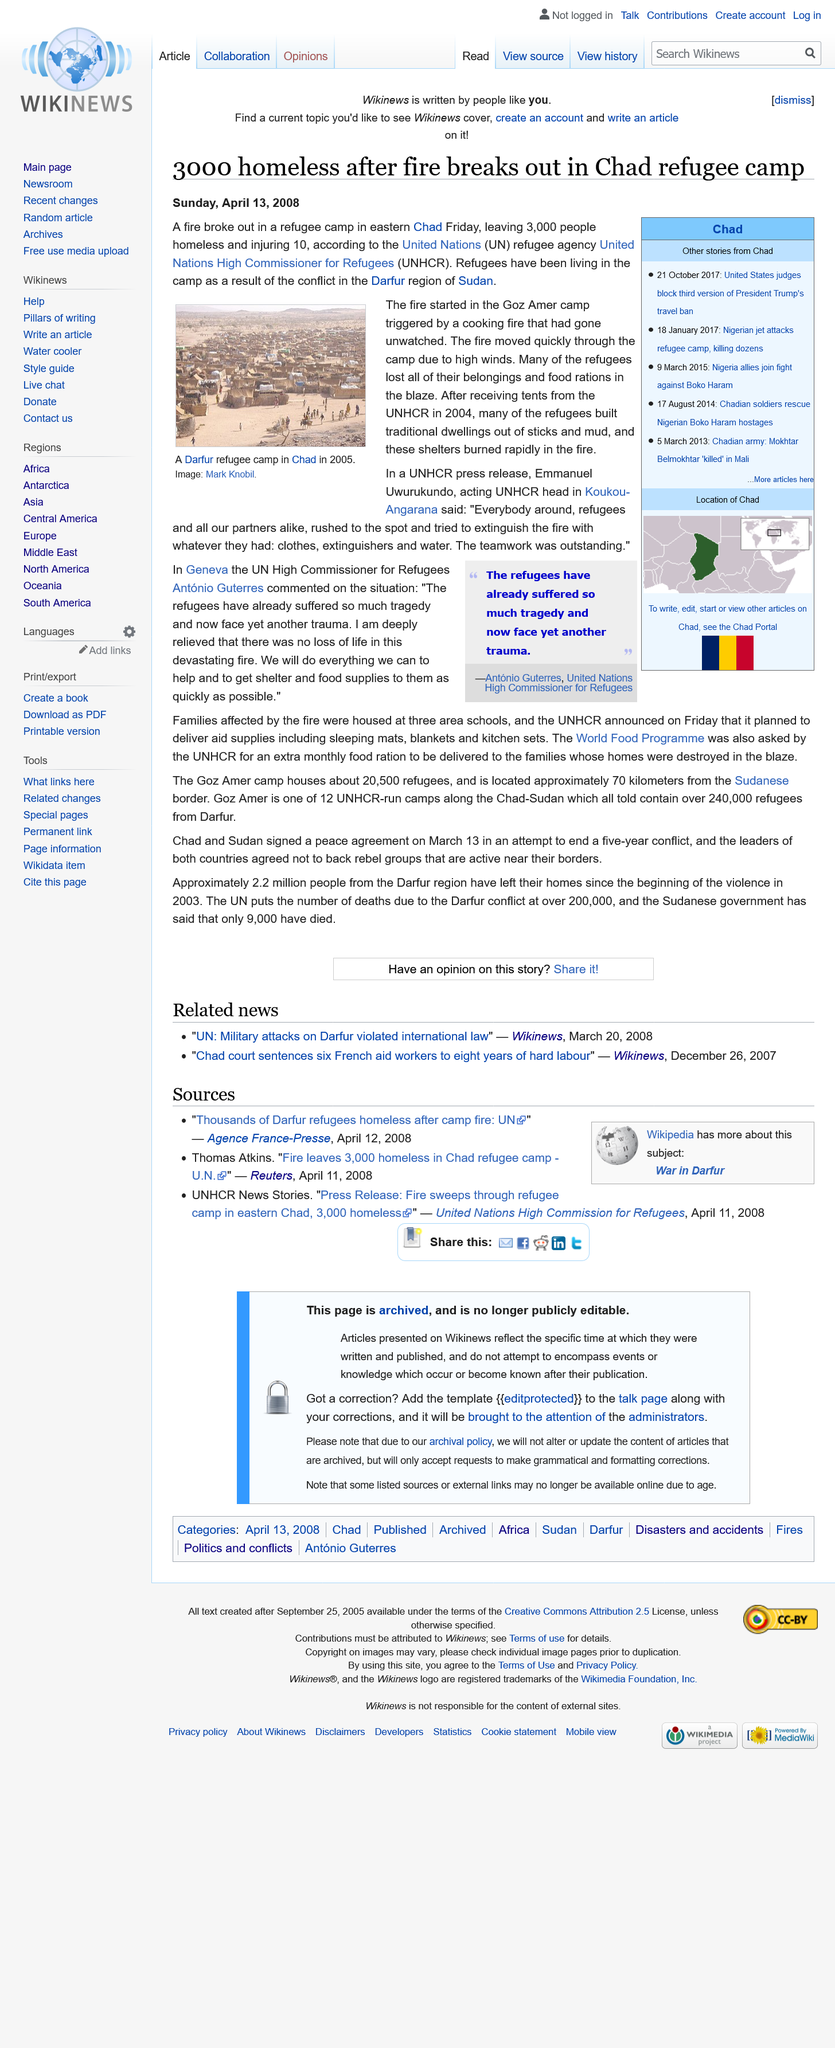Mention a couple of crucial points in this snapshot. UNHCR stands for the United Nations High Commissioner for Refugees, which is an international organization responsible for providing humanitarian assistance and protection to refugees and displaced persons. According to the UNHCR, 3000 people were left homeless as a result of the fire. The fire at the refugee camp in eastern Chad was caused by an unattended cooking fire that had escaped control. 